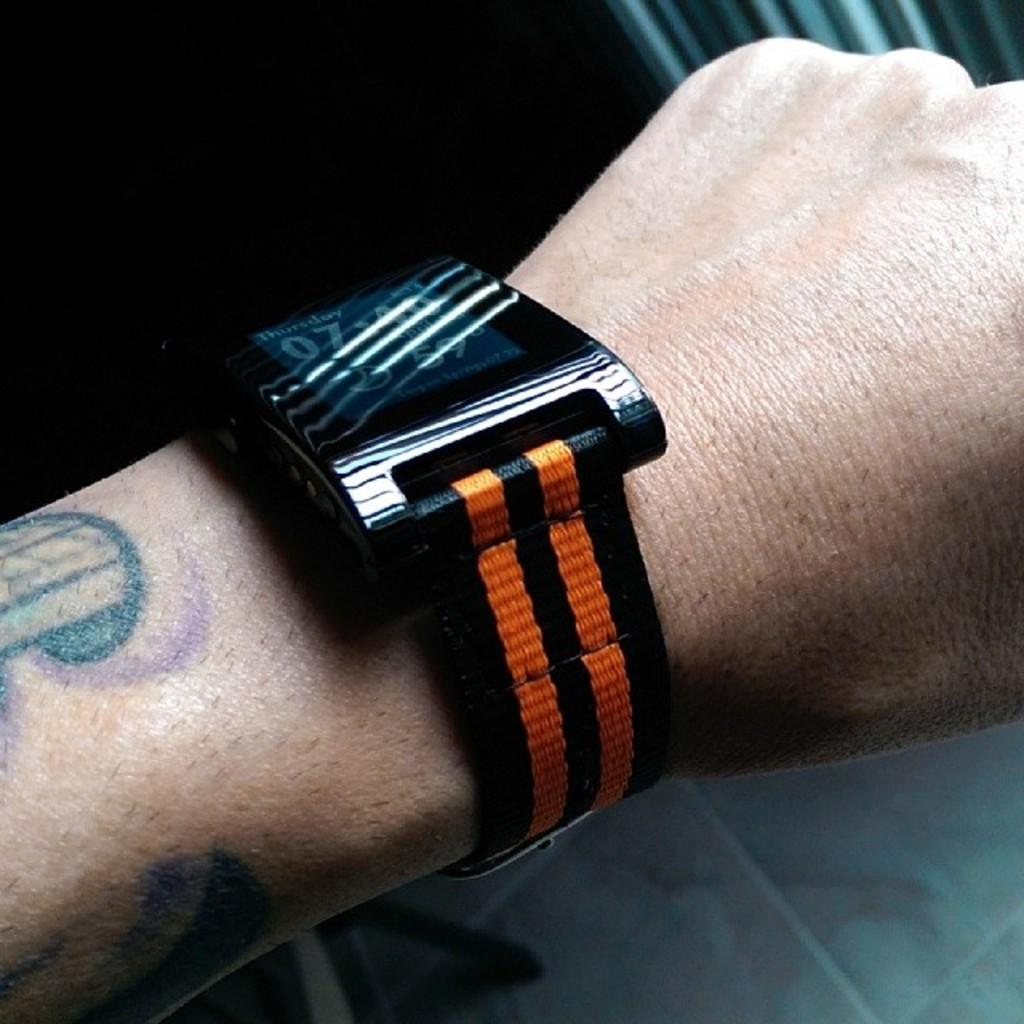What is present in the image? There is a person in the image. Can you describe any specific detail about the person? The person is wearing a watch. What type of comfort does the person provide in the image? The image does not provide any information about the person providing comfort. Is the person playing a game of chess in the image? There is no indication in the image that the person is playing chess. Can you see an airplane in the image? There is no airplane present in the image. 